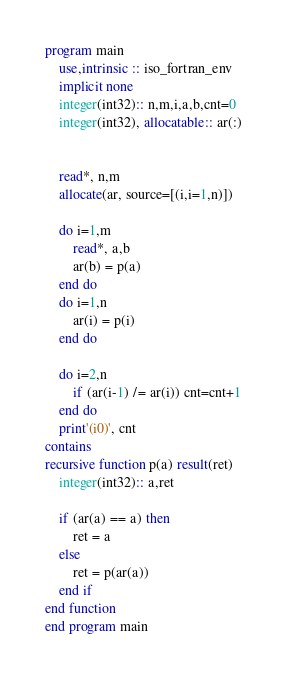Convert code to text. <code><loc_0><loc_0><loc_500><loc_500><_FORTRAN_>program main
    use,intrinsic :: iso_fortran_env
    implicit none
    integer(int32):: n,m,i,a,b,cnt=0
    integer(int32), allocatable:: ar(:)


    read*, n,m
    allocate(ar, source=[(i,i=1,n)])

    do i=1,m
        read*, a,b
        ar(b) = p(a)
    end do
    do i=1,n
        ar(i) = p(i)
    end do

    do i=2,n
        if (ar(i-1) /= ar(i)) cnt=cnt+1
    end do
    print'(i0)', cnt
contains
recursive function p(a) result(ret)
    integer(int32):: a,ret

    if (ar(a) == a) then
        ret = a
    else
        ret = p(ar(a))
    end if
end function
end program main</code> 